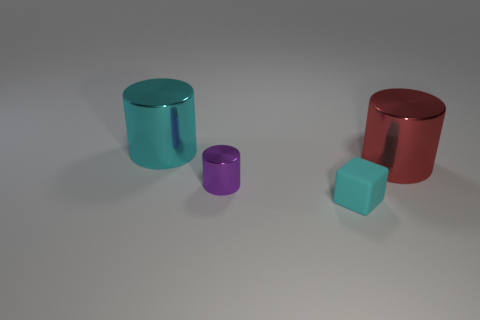What is the material of the red cylinder?
Ensure brevity in your answer.  Metal. There is a tiny cyan cube; are there any things in front of it?
Your response must be concise. No. There is a thing that is left of the small purple shiny thing; how many small purple things are behind it?
Your response must be concise. 0. What material is the block that is the same size as the purple metal cylinder?
Provide a short and direct response. Rubber. How many other objects are the same material as the large cyan thing?
Make the answer very short. 2. There is a large cyan object; how many small cyan blocks are in front of it?
Your answer should be compact. 1. What number of cylinders are big shiny objects or purple things?
Offer a terse response. 3. What size is the thing that is to the right of the small purple metallic cylinder and left of the red metal object?
Your response must be concise. Small. How many other objects are the same color as the rubber thing?
Offer a terse response. 1. Do the cyan cylinder and the cyan thing in front of the tiny purple metallic cylinder have the same material?
Ensure brevity in your answer.  No. 